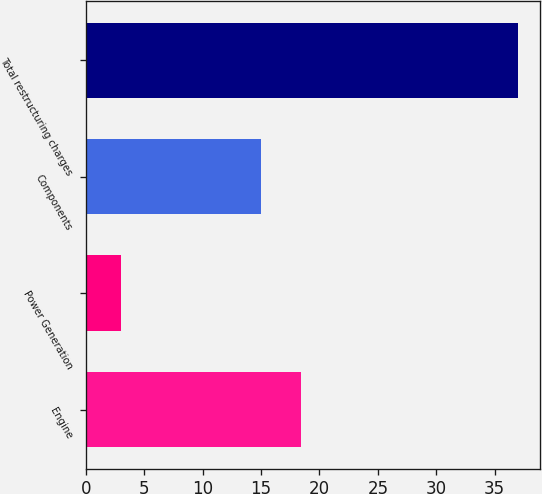<chart> <loc_0><loc_0><loc_500><loc_500><bar_chart><fcel>Engine<fcel>Power Generation<fcel>Components<fcel>Total restructuring charges<nl><fcel>18.4<fcel>3<fcel>15<fcel>37<nl></chart> 